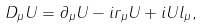Convert formula to latex. <formula><loc_0><loc_0><loc_500><loc_500>D _ { \mu } U = \partial _ { \mu } U - i r _ { \mu } U + i U l _ { \mu } ,</formula> 